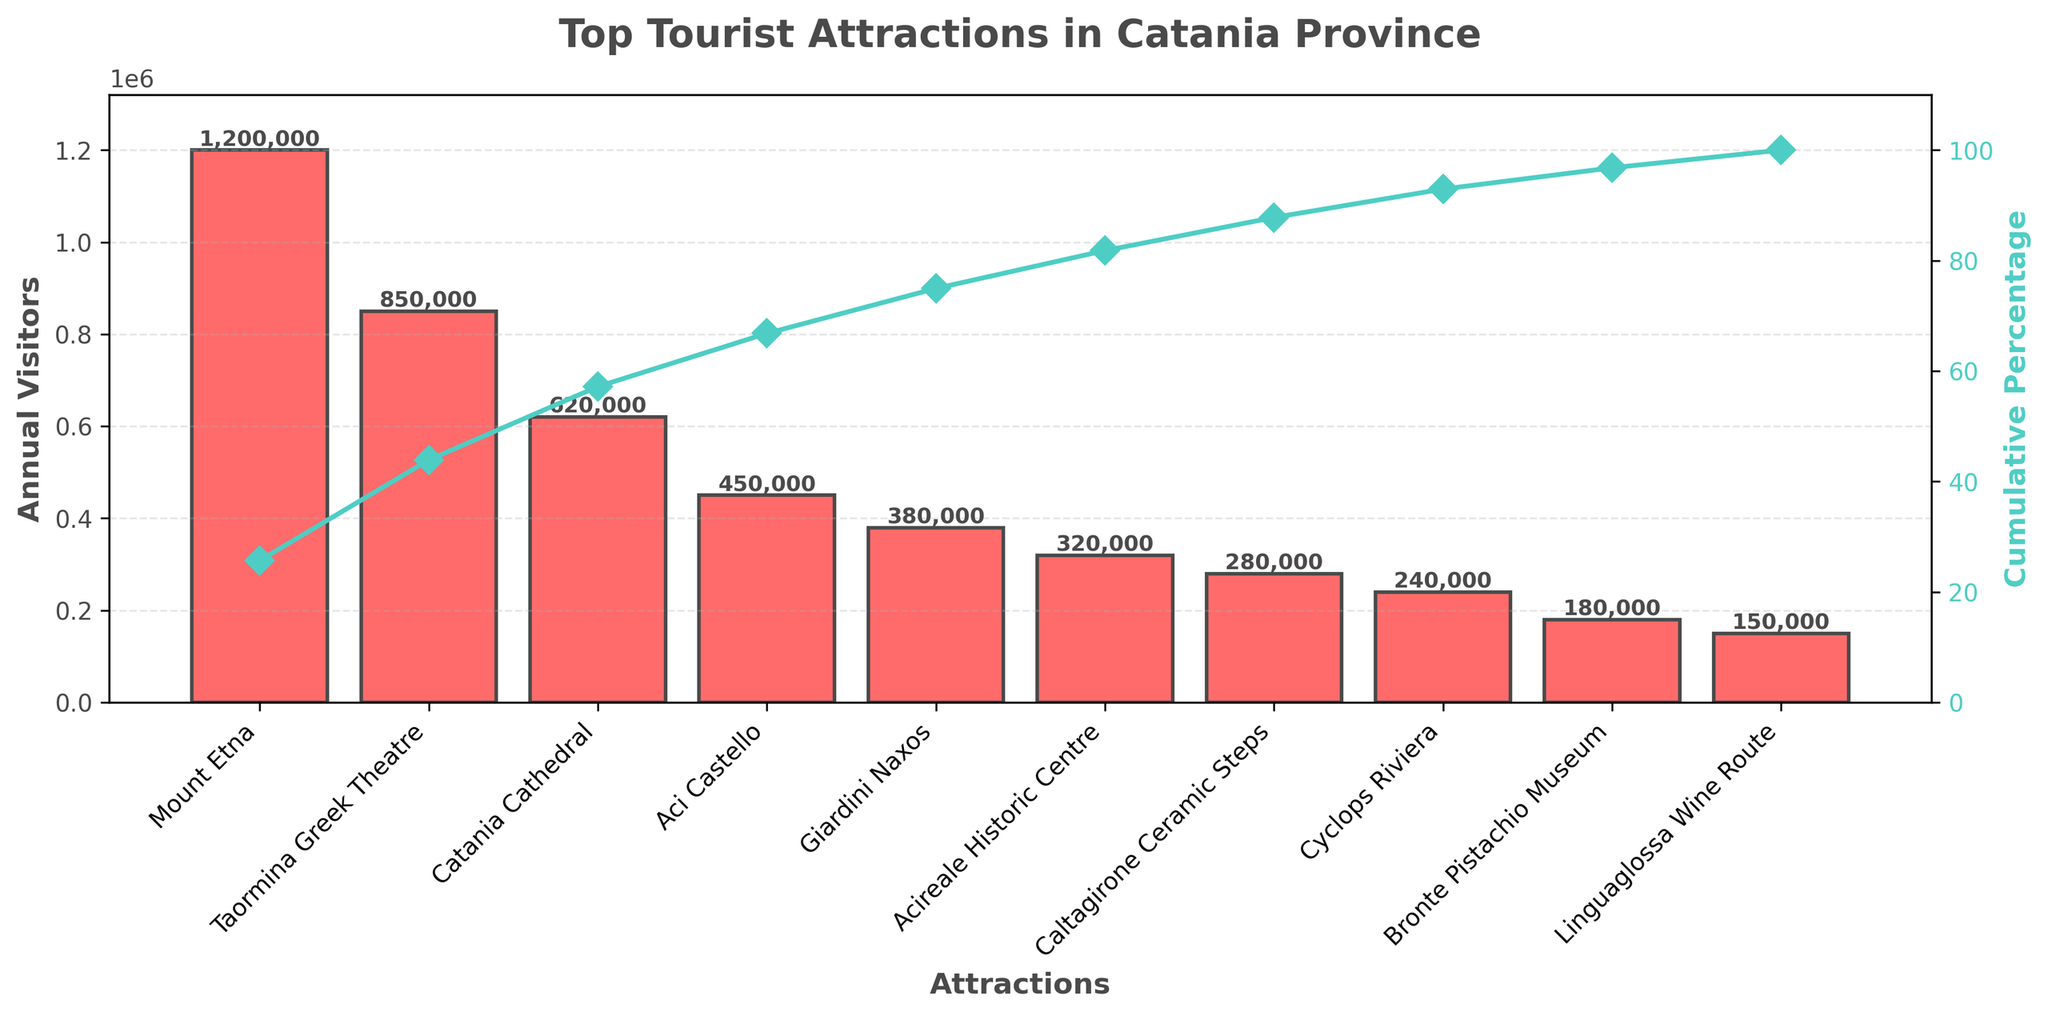What is the most visited tourist attraction in Catania province? The bar with the highest value represents the most visited attraction, which is Mount Etna.
Answer: Mount Etna What is the cumulative percentage of visitors for the top two attractions? The Pareto chart shows cumulative percentages along the line graph. Adding the cumulative percentages for Mount Etna and Taormina Greek Theatre gives approximately 37% + 67% = 104%.
Answer: 67% Which attraction has roughly the 50% mark in the cumulative percentage? Looking at the line graph, the attraction where the cumulative percentage crosses the 50% mark is Taormina Greek Theatre.
Answer: Taormina Greek Theatre How many tourist attractions have more than 300,000 annual visitors? Counting the bars with values greater than 300,000, we can see four such attractions: Mount Etna, Taormina Greek Theatre, Catania Cathedral, and Aci Castello.
Answer: Four What's the total number of annual visitors for the top three attractions combined? Sum the visitors for Mount Etna (1,200,000), Taormina Greek Theatre (850,000), and Catania Cathedral (620,000): 1,200,000 + 850,000 + 620,000 = 2,670,000.
Answer: 2,670,000 What percentage of visitors comes from the bottom five attractions? Calculate the cumulative percentage of visitors except for the top five. The bottom five are Bronte Pistachio Museum, Linguaglossa Wine Route, Cyclops Riviera, Caltagirone Ceramic Steps, and Acireale Historic Centre. The cumulative percentage for these is 100% - 86% = 14%.
Answer: 14% Which attraction contributes the least to the overall number of visitors? The bar with the smallest height is for Linguaglossa Wine Route.
Answer: Linguaglossa Wine Route How many attractions contribute to 80% of the total visitors? On the line graph, find where the cumulative percentage first crosses 80%. This occurs after Caltagirone Ceramic Steps, which means the first six attractions contribute to 80% of the visitors.
Answer: Six 